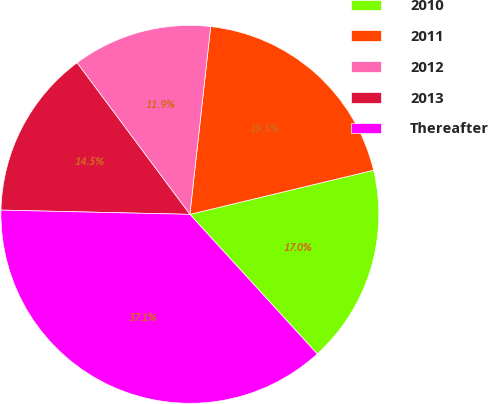<chart> <loc_0><loc_0><loc_500><loc_500><pie_chart><fcel>2010<fcel>2011<fcel>2012<fcel>2013<fcel>Thereafter<nl><fcel>16.98%<fcel>19.5%<fcel>11.94%<fcel>14.46%<fcel>37.14%<nl></chart> 